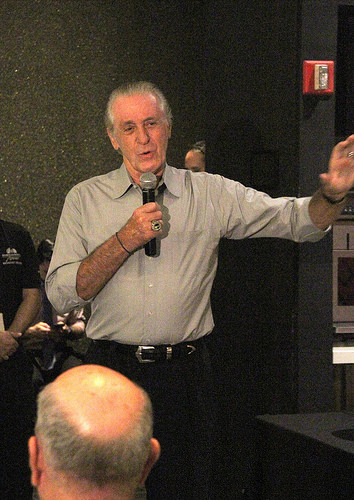<image>
Can you confirm if the man is next to the microphone? No. The man is not positioned next to the microphone. They are located in different areas of the scene. 